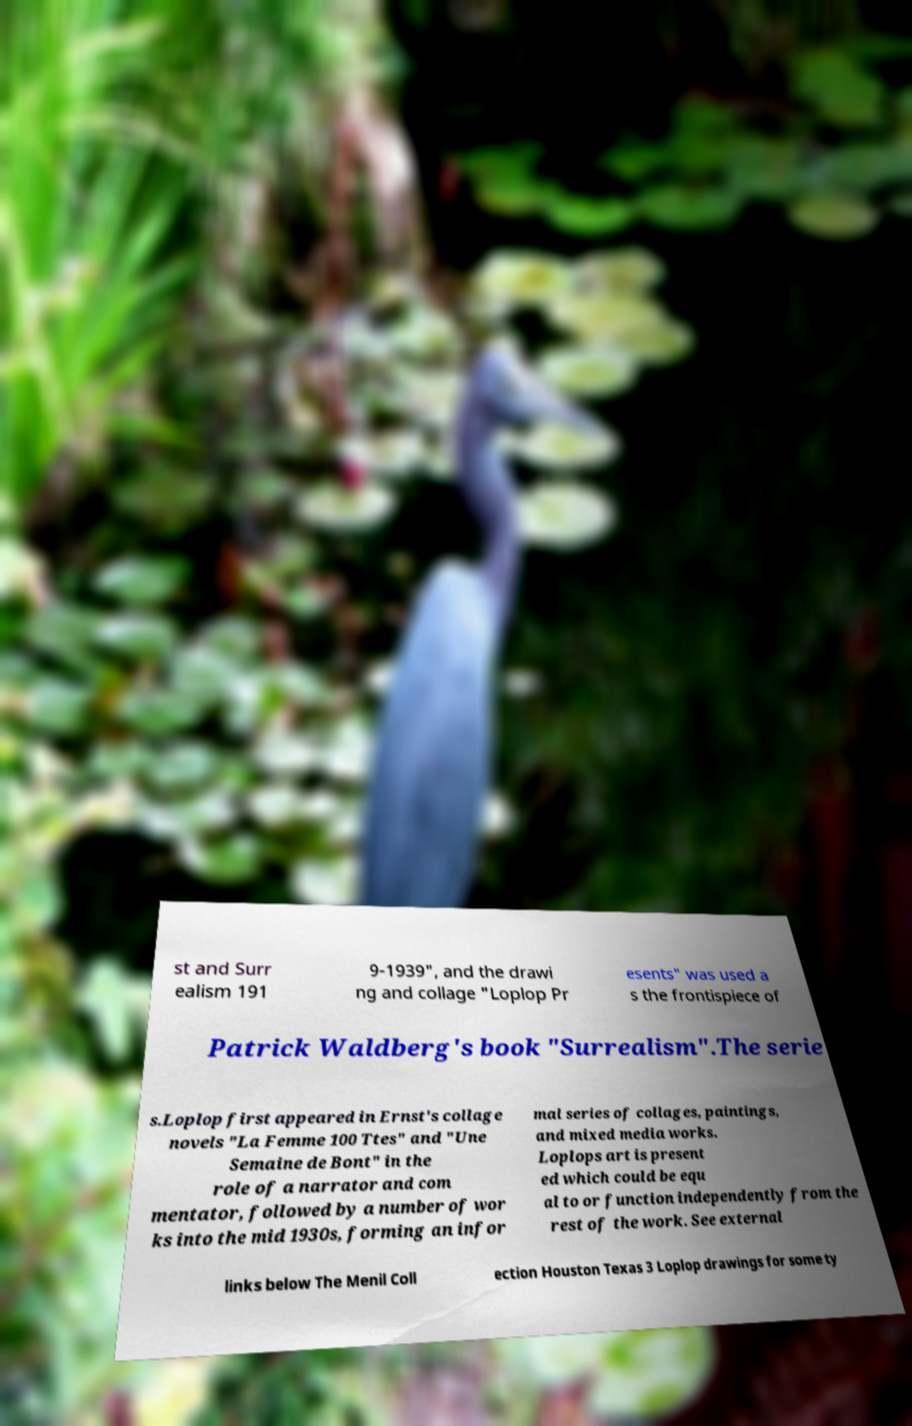For documentation purposes, I need the text within this image transcribed. Could you provide that? st and Surr ealism 191 9-1939", and the drawi ng and collage "Loplop Pr esents" was used a s the frontispiece of Patrick Waldberg's book "Surrealism".The serie s.Loplop first appeared in Ernst's collage novels "La Femme 100 Ttes" and "Une Semaine de Bont" in the role of a narrator and com mentator, followed by a number of wor ks into the mid 1930s, forming an infor mal series of collages, paintings, and mixed media works. Loplops art is present ed which could be equ al to or function independently from the rest of the work. See external links below The Menil Coll ection Houston Texas 3 Loplop drawings for some ty 